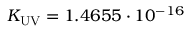<formula> <loc_0><loc_0><loc_500><loc_500>K _ { U V } = 1 . 4 6 5 5 \cdot 1 0 ^ { - 1 6 }</formula> 